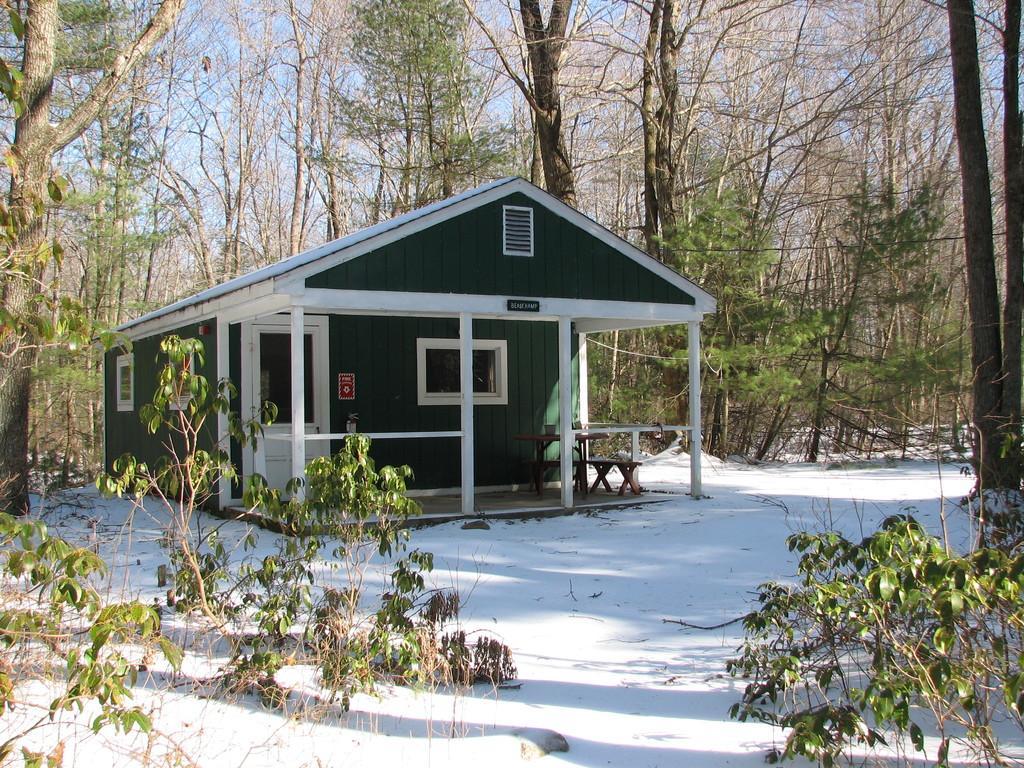How would you summarize this image in a sentence or two? In this picture we can see a house and in front of the house there is snow and plants. Behind the house there are trees and a sky. 